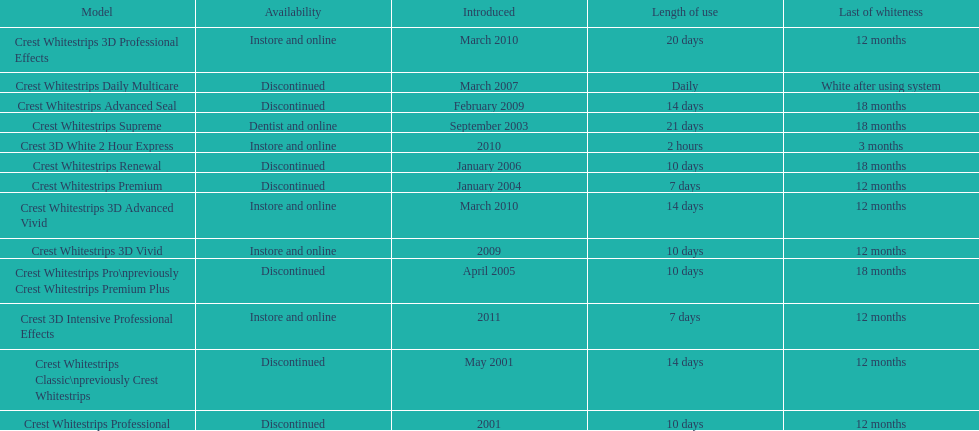Tell me the number of products that give you 12 months of whiteness. 7. 